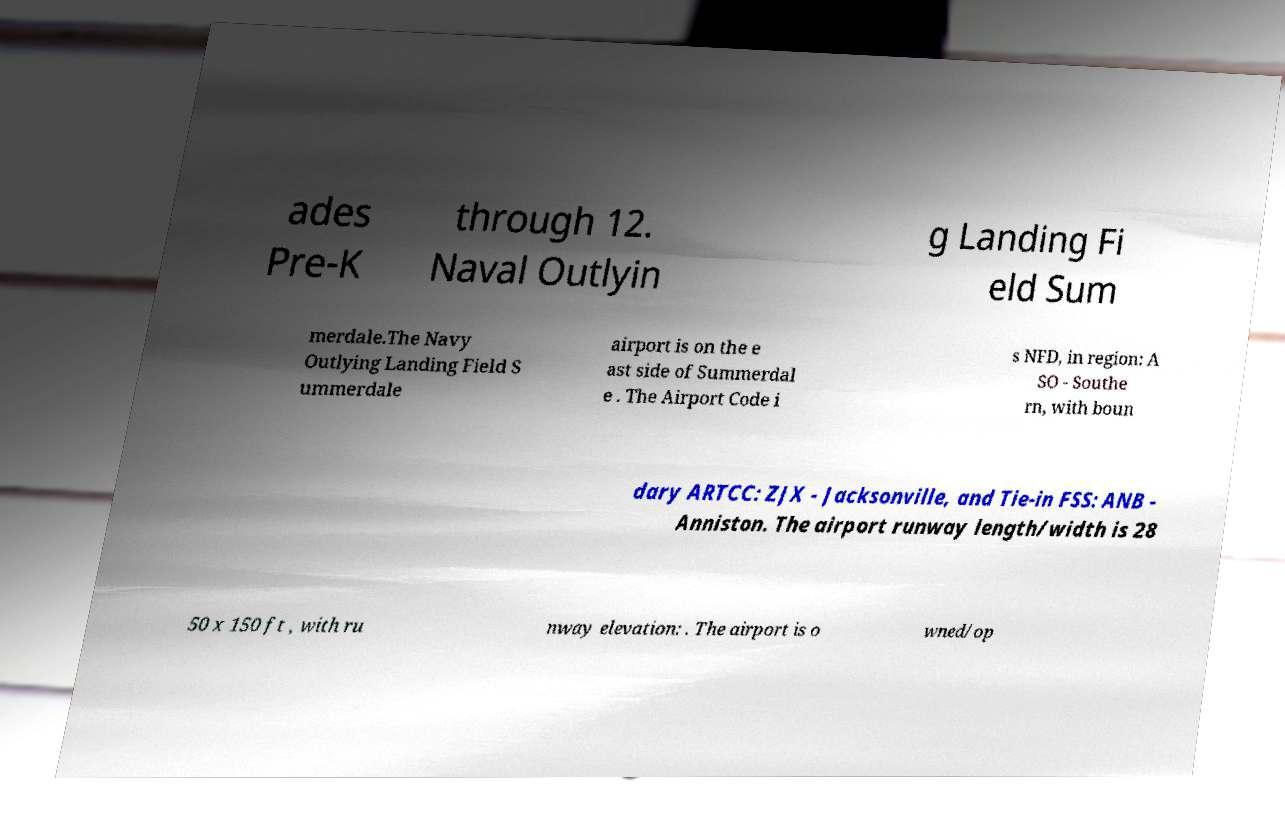There's text embedded in this image that I need extracted. Can you transcribe it verbatim? ades Pre-K through 12. Naval Outlyin g Landing Fi eld Sum merdale.The Navy Outlying Landing Field S ummerdale airport is on the e ast side of Summerdal e . The Airport Code i s NFD, in region: A SO - Southe rn, with boun dary ARTCC: ZJX - Jacksonville, and Tie-in FSS: ANB - Anniston. The airport runway length/width is 28 50 x 150 ft , with ru nway elevation: . The airport is o wned/op 